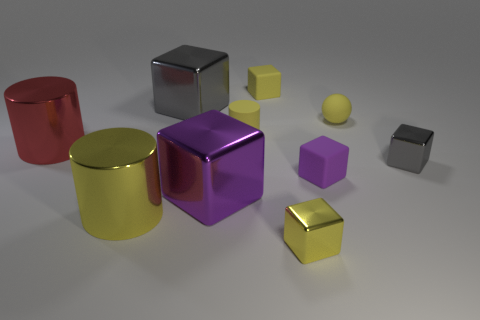Subtract all yellow cylinders. How many cylinders are left? 1 Subtract all purple blocks. How many blocks are left? 4 Subtract 1 spheres. How many spheres are left? 0 Subtract all red spheres. How many yellow cubes are left? 2 Subtract all cubes. How many objects are left? 4 Subtract all gray cylinders. Subtract all brown cubes. How many cylinders are left? 3 Subtract all yellow cubes. Subtract all purple metallic cubes. How many objects are left? 7 Add 3 small rubber objects. How many small rubber objects are left? 7 Add 9 red metal balls. How many red metal balls exist? 9 Subtract 0 green balls. How many objects are left? 10 